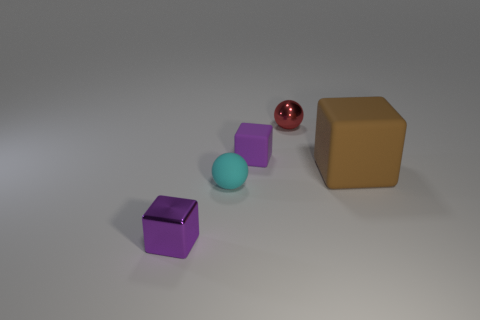How many tiny things are either green metallic spheres or cubes?
Give a very brief answer. 2. Are there fewer cyan objects than small matte things?
Offer a terse response. Yes. Is there anything else that is the same size as the brown block?
Provide a succinct answer. No. Does the tiny metal block have the same color as the small rubber cube?
Give a very brief answer. Yes. Is the number of small matte cylinders greater than the number of small cyan rubber objects?
Your response must be concise. No. How many other objects are the same color as the big cube?
Provide a short and direct response. 0. How many red things are behind the ball that is in front of the shiny ball?
Make the answer very short. 1. Are there any tiny red metal balls to the left of the metallic ball?
Your answer should be compact. No. There is a small shiny object to the right of the metal thing to the left of the red metallic object; what is its shape?
Your response must be concise. Sphere. Is the number of cyan objects on the right side of the small metallic sphere less than the number of small purple things behind the brown object?
Provide a short and direct response. Yes. 